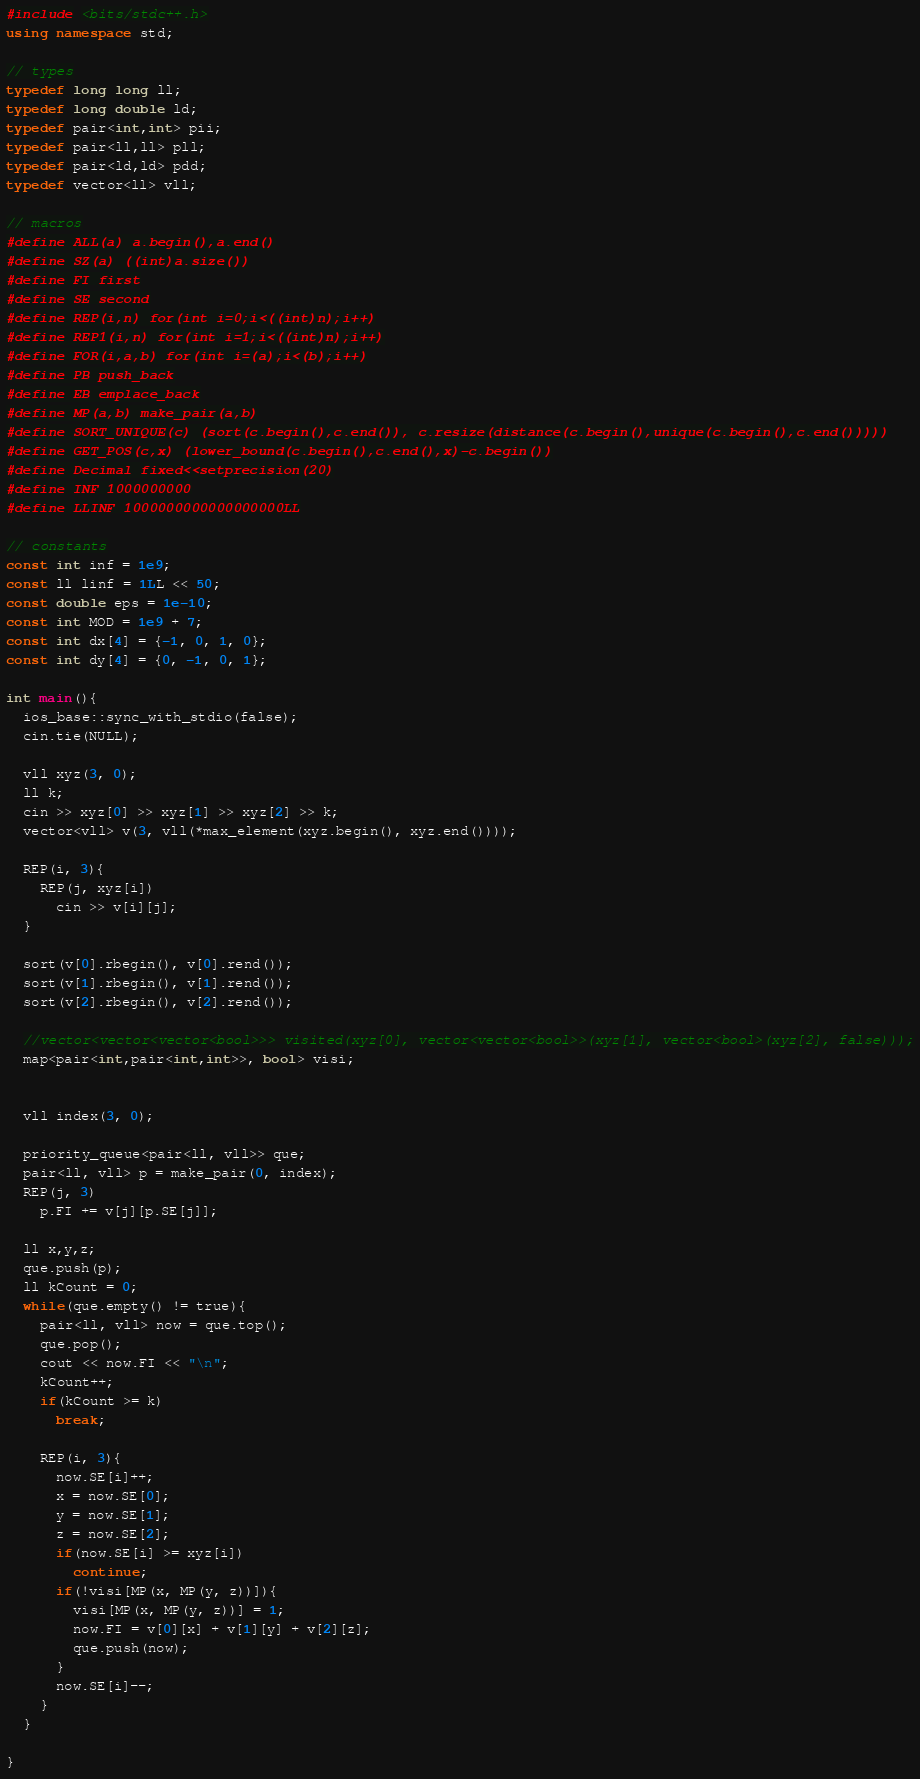<code> <loc_0><loc_0><loc_500><loc_500><_C++_>#include <bits/stdc++.h>
using namespace std;

// types
typedef long long ll;
typedef long double ld;
typedef pair<int,int> pii;
typedef pair<ll,ll> pll;
typedef pair<ld,ld> pdd;
typedef vector<ll> vll;

// macros
#define ALL(a) a.begin(),a.end()
#define SZ(a) ((int)a.size())
#define FI first
#define SE second
#define REP(i,n) for(int i=0;i<((int)n);i++)
#define REP1(i,n) for(int i=1;i<((int)n);i++)
#define FOR(i,a,b) for(int i=(a);i<(b);i++)
#define PB push_back
#define EB emplace_back
#define MP(a,b) make_pair(a,b)
#define SORT_UNIQUE(c) (sort(c.begin(),c.end()), c.resize(distance(c.begin(),unique(c.begin(),c.end()))))
#define GET_POS(c,x) (lower_bound(c.begin(),c.end(),x)-c.begin())
#define Decimal fixed<<setprecision(20)
#define INF 1000000000
#define LLINF 1000000000000000000LL

// constants
const int inf = 1e9;
const ll linf = 1LL << 50;
const double eps = 1e-10;
const int MOD = 1e9 + 7;
const int dx[4] = {-1, 0, 1, 0};
const int dy[4] = {0, -1, 0, 1};

int main(){
  ios_base::sync_with_stdio(false);
  cin.tie(NULL);

  vll xyz(3, 0);
  ll k;
  cin >> xyz[0] >> xyz[1] >> xyz[2] >> k;
  vector<vll> v(3, vll(*max_element(xyz.begin(), xyz.end())));

  REP(i, 3){
    REP(j, xyz[i])
      cin >> v[i][j];
  }

  sort(v[0].rbegin(), v[0].rend());
  sort(v[1].rbegin(), v[1].rend());
  sort(v[2].rbegin(), v[2].rend());

  //vector<vector<vector<bool>>> visited(xyz[0], vector<vector<bool>>(xyz[1], vector<bool>(xyz[2], false)));
  map<pair<int,pair<int,int>>, bool> visi;

 
  vll index(3, 0);

  priority_queue<pair<ll, vll>> que;
  pair<ll, vll> p = make_pair(0, index);
  REP(j, 3)
    p.FI += v[j][p.SE[j]];

  ll x,y,z;
  que.push(p);
  ll kCount = 0;
  while(que.empty() != true){
    pair<ll, vll> now = que.top();
    que.pop();
    cout << now.FI << "\n";
    kCount++;
    if(kCount >= k)
      break;

    REP(i, 3){
      now.SE[i]++;
      x = now.SE[0];
      y = now.SE[1];
      z = now.SE[2];
      if(now.SE[i] >= xyz[i])
        continue;
      if(!visi[MP(x, MP(y, z))]){
        visi[MP(x, MP(y, z))] = 1;
        now.FI = v[0][x] + v[1][y] + v[2][z];
        que.push(now);
      }
      now.SE[i]--;
    }
  }

}
</code> 